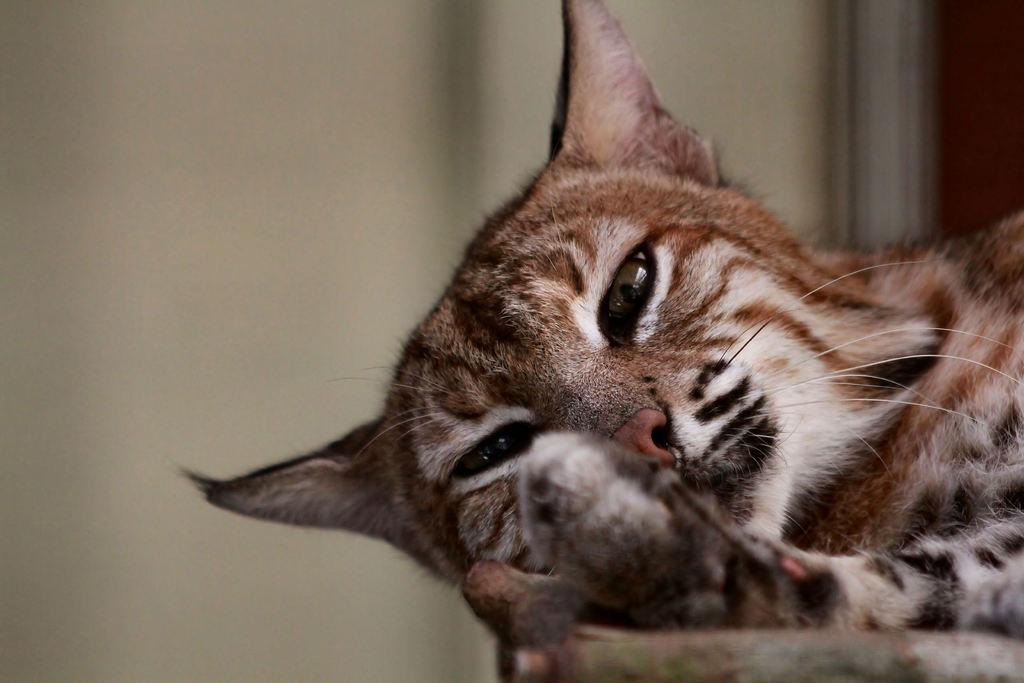What type of animal is in the image? There is a truncated cat in the image. Can you describe the cat's position or orientation? The cat is on a surface. What can be seen behind the cat in the image? There is a white wall behind the cat. What type of straw is the secretary using to drink from in the image? There is no straw or secretary present in the image; it features a truncated cat on a surface with a white wall behind it. 